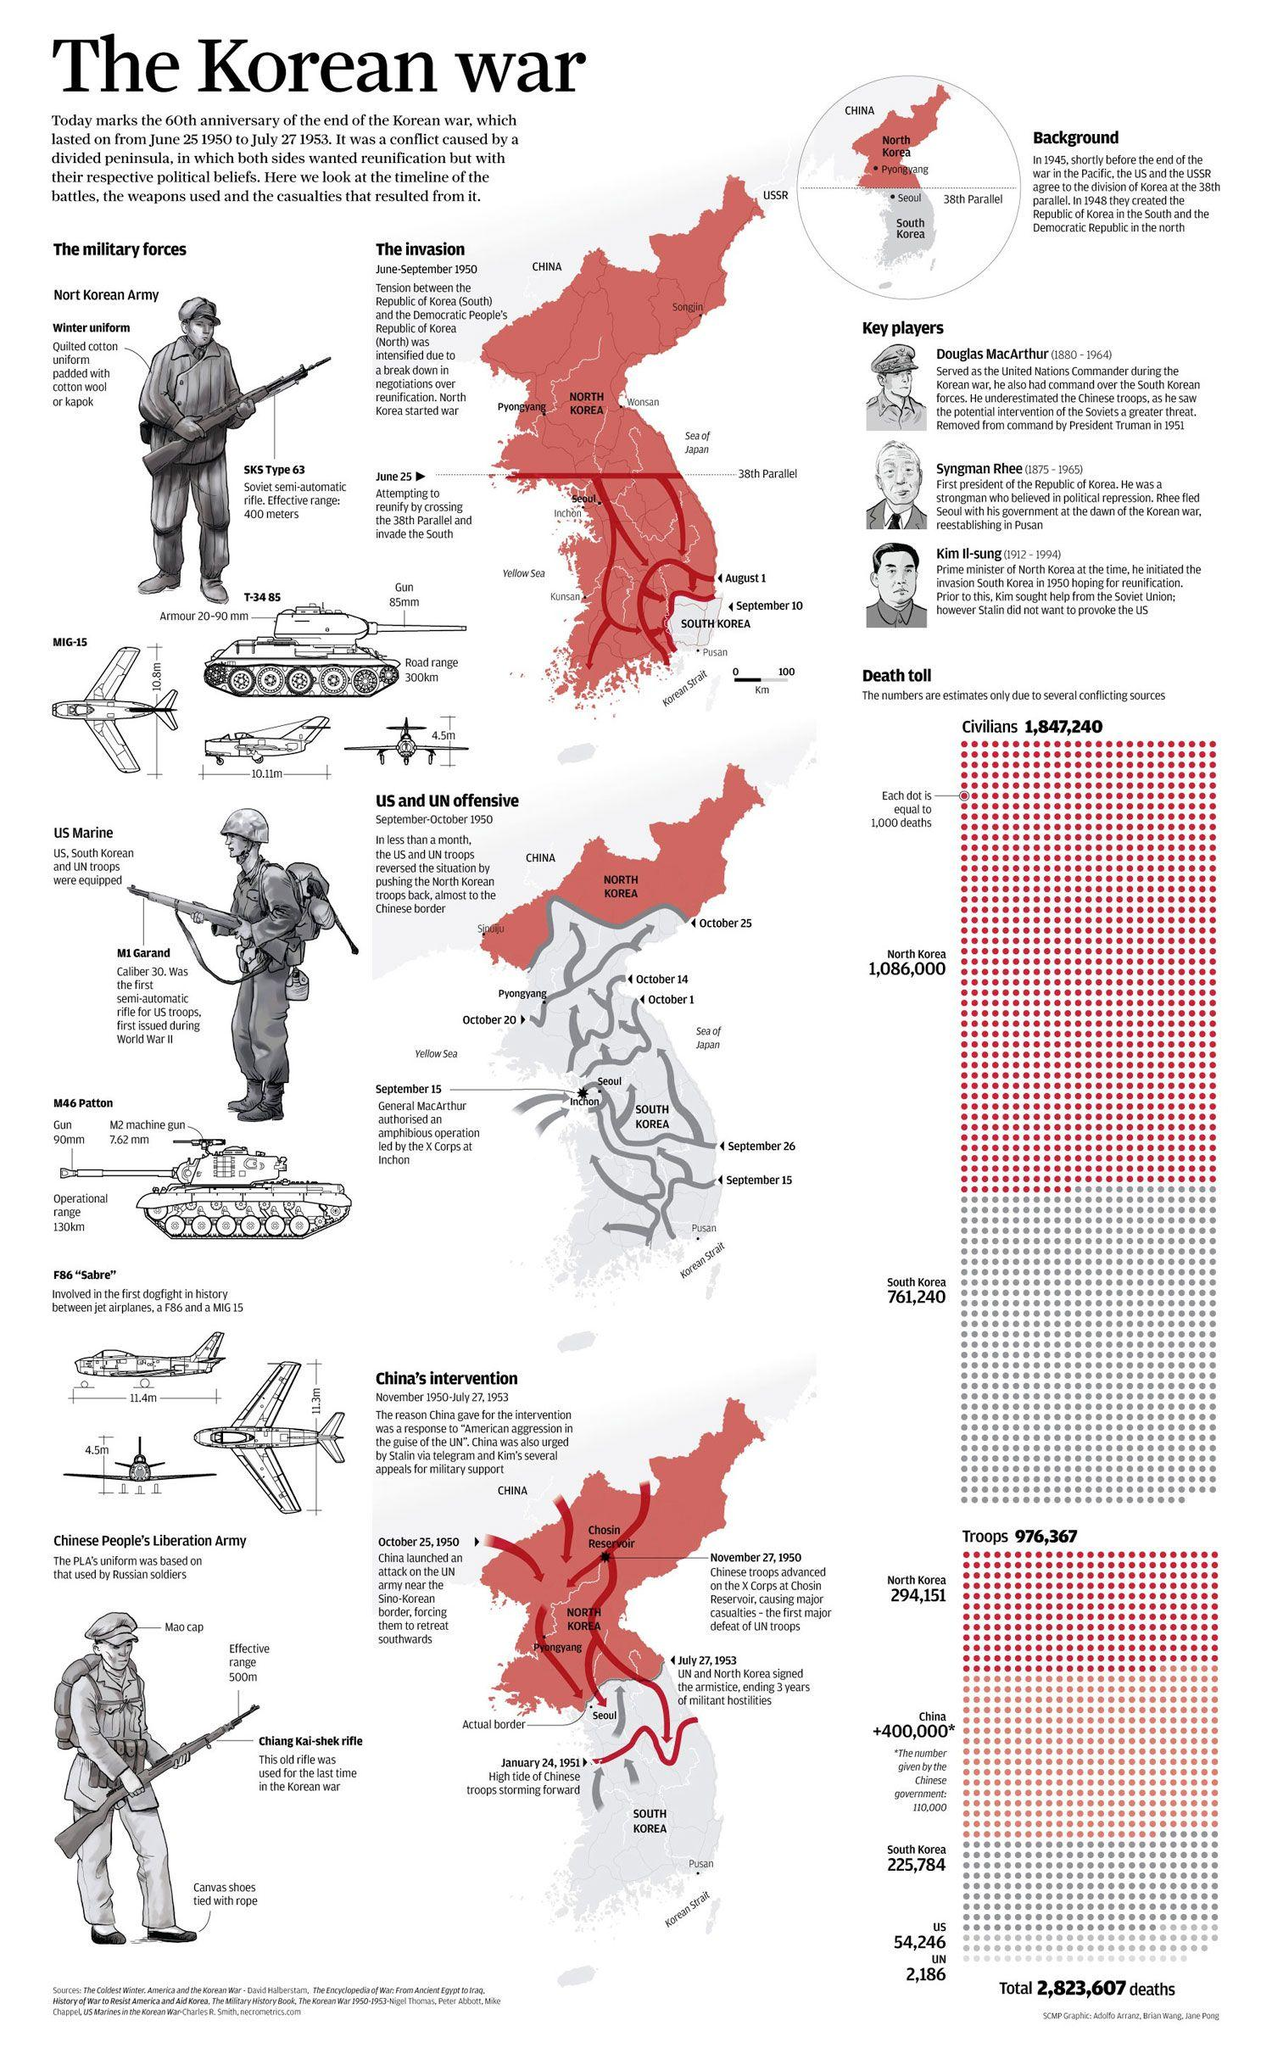Indicate a few pertinent items in this graphic. The Korean War began on June 25, 1950. During the Korean War, a total of 54,246 US military troops suffered casualties, reported casualties. The SKS Type 63 rifle has an effective firing range of up to 400 meters. During the Korean War, a total of 761,240 deaths were reported in South Korea. The T-34 85 has a maximum road range of 300 kilometers. 